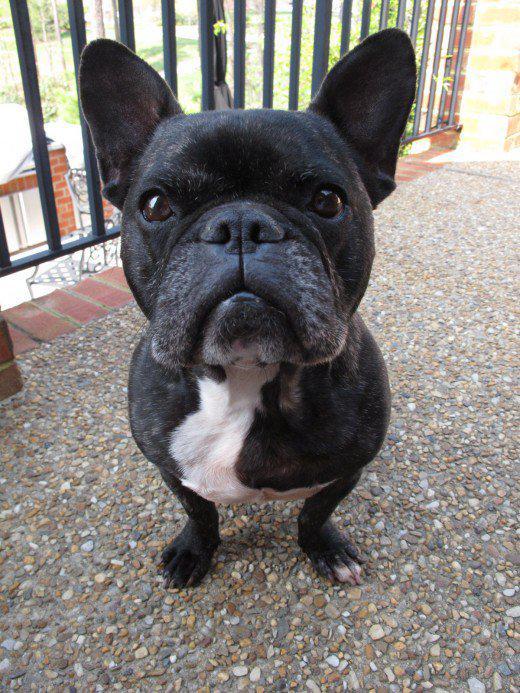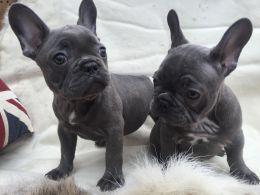The first image is the image on the left, the second image is the image on the right. Analyze the images presented: Is the assertion "There are three dogs." valid? Answer yes or no. Yes. The first image is the image on the left, the second image is the image on the right. Considering the images on both sides, is "One image includes exactly twice as many big-eared dogs in the foreground as the other image." valid? Answer yes or no. Yes. 